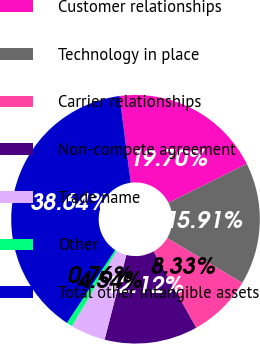Convert chart to OTSL. <chart><loc_0><loc_0><loc_500><loc_500><pie_chart><fcel>Customer relationships<fcel>Technology in place<fcel>Carrier relationships<fcel>Non-compete agreement<fcel>Trade name<fcel>Other<fcel>Total other intangible assets<nl><fcel>19.7%<fcel>15.91%<fcel>8.33%<fcel>12.12%<fcel>4.54%<fcel>0.76%<fcel>38.64%<nl></chart> 